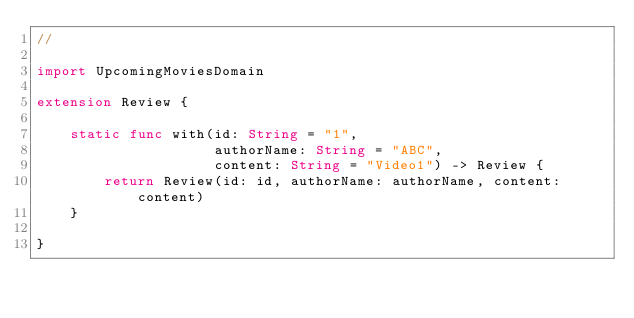<code> <loc_0><loc_0><loc_500><loc_500><_Swift_>//

import UpcomingMoviesDomain

extension Review {
    
    static func with(id: String = "1",
                     authorName: String = "ABC",
                     content: String = "Video1") -> Review {
        return Review(id: id, authorName: authorName, content: content)
    }
    
}
</code> 